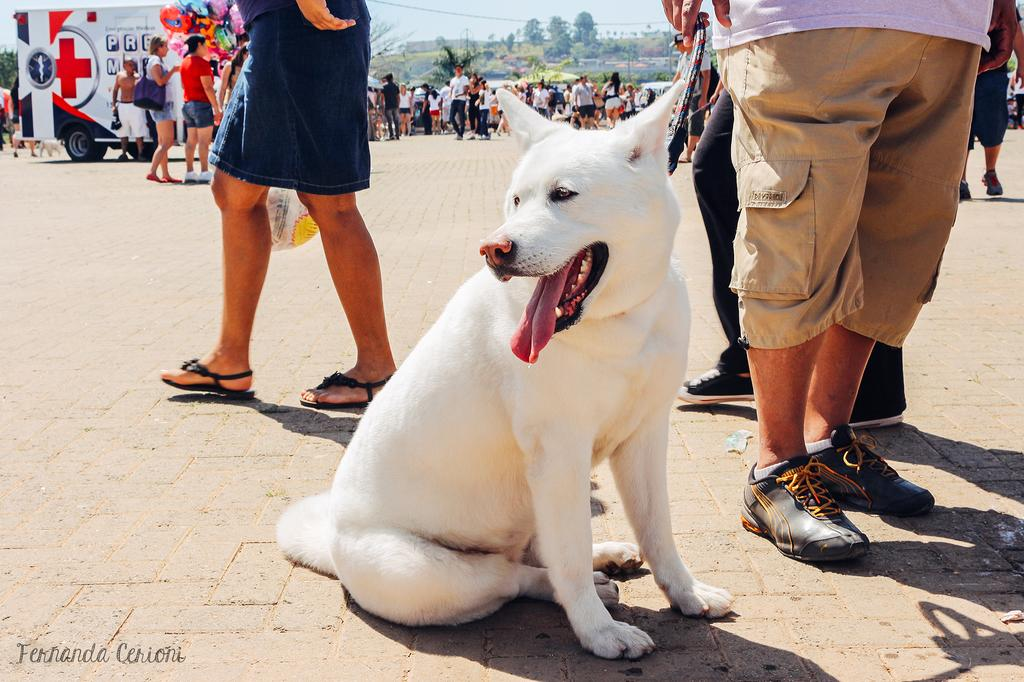What animal is present in the image? There is a dog in the image. What is the dog doing in the image? The dog is sitting on the ground. What are the people in the image doing? The people are walking on the street. What type of powder can be seen on the dog's ear in the image? There is no powder visible on the dog's ear in the image, and the dog does not have a mask. 